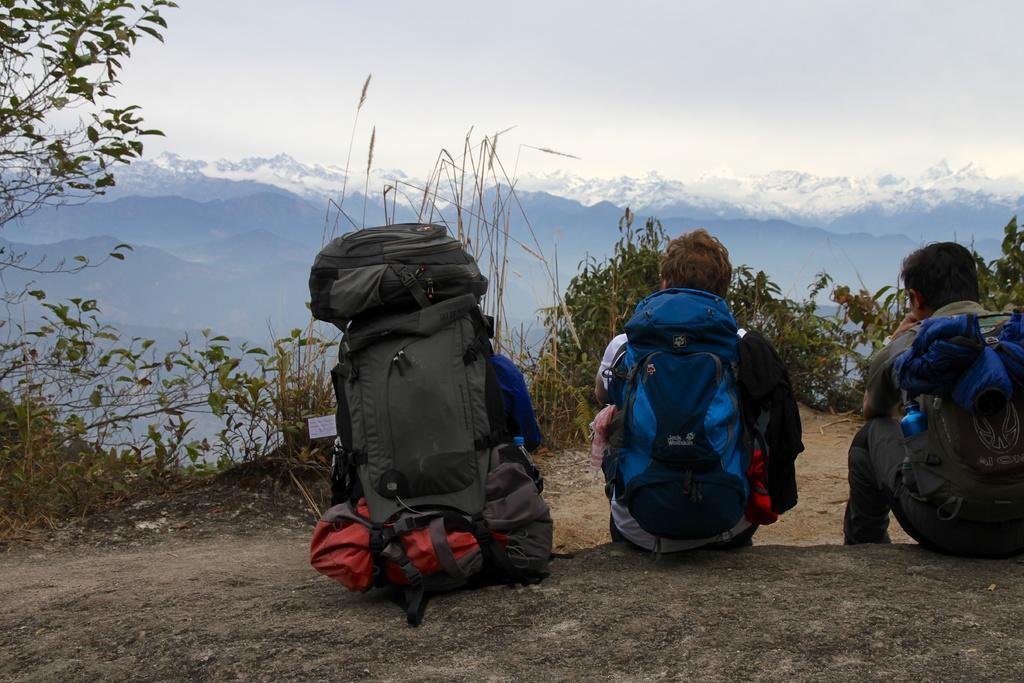Could you give a brief overview of what you see in this image? This is the image outside of the city. There are three persons in the image. At the back there are mountains, at the top there is a sky and at the left there are plants. 